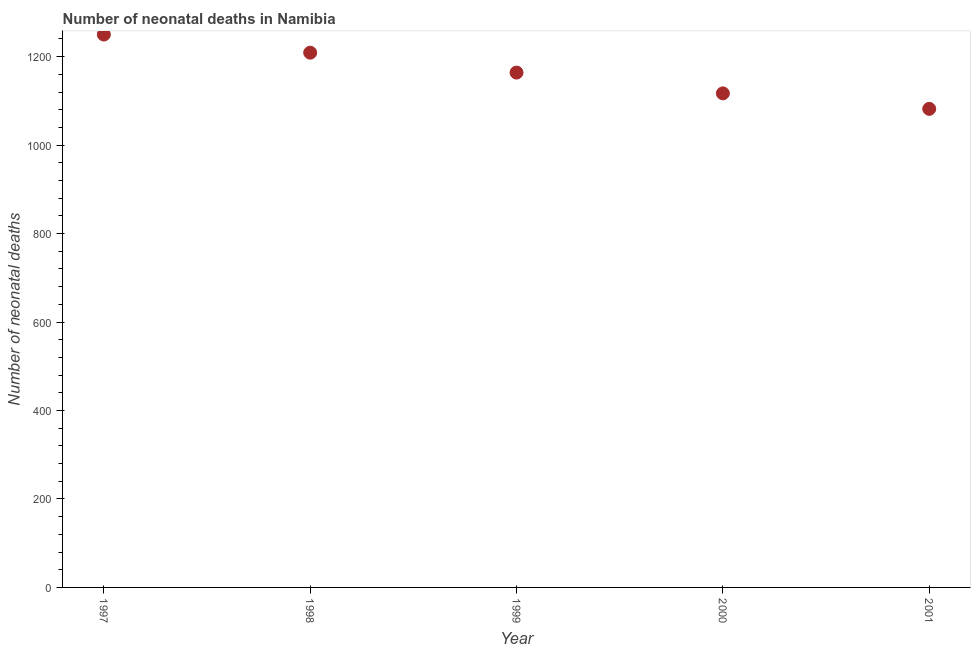What is the number of neonatal deaths in 2001?
Ensure brevity in your answer.  1082. Across all years, what is the maximum number of neonatal deaths?
Offer a terse response. 1250. Across all years, what is the minimum number of neonatal deaths?
Provide a succinct answer. 1082. In which year was the number of neonatal deaths maximum?
Provide a succinct answer. 1997. In which year was the number of neonatal deaths minimum?
Make the answer very short. 2001. What is the sum of the number of neonatal deaths?
Ensure brevity in your answer.  5822. What is the difference between the number of neonatal deaths in 1998 and 2000?
Provide a short and direct response. 92. What is the average number of neonatal deaths per year?
Provide a short and direct response. 1164.4. What is the median number of neonatal deaths?
Your response must be concise. 1164. What is the ratio of the number of neonatal deaths in 1999 to that in 2000?
Offer a very short reply. 1.04. Is the number of neonatal deaths in 1997 less than that in 1998?
Offer a terse response. No. Is the sum of the number of neonatal deaths in 1997 and 2001 greater than the maximum number of neonatal deaths across all years?
Offer a terse response. Yes. What is the difference between the highest and the lowest number of neonatal deaths?
Give a very brief answer. 168. In how many years, is the number of neonatal deaths greater than the average number of neonatal deaths taken over all years?
Provide a succinct answer. 2. Does the number of neonatal deaths monotonically increase over the years?
Ensure brevity in your answer.  No. How many years are there in the graph?
Offer a terse response. 5. Are the values on the major ticks of Y-axis written in scientific E-notation?
Give a very brief answer. No. Does the graph contain grids?
Offer a terse response. No. What is the title of the graph?
Your answer should be compact. Number of neonatal deaths in Namibia. What is the label or title of the Y-axis?
Offer a very short reply. Number of neonatal deaths. What is the Number of neonatal deaths in 1997?
Offer a very short reply. 1250. What is the Number of neonatal deaths in 1998?
Provide a short and direct response. 1209. What is the Number of neonatal deaths in 1999?
Keep it short and to the point. 1164. What is the Number of neonatal deaths in 2000?
Make the answer very short. 1117. What is the Number of neonatal deaths in 2001?
Your answer should be very brief. 1082. What is the difference between the Number of neonatal deaths in 1997 and 1998?
Make the answer very short. 41. What is the difference between the Number of neonatal deaths in 1997 and 2000?
Provide a short and direct response. 133. What is the difference between the Number of neonatal deaths in 1997 and 2001?
Ensure brevity in your answer.  168. What is the difference between the Number of neonatal deaths in 1998 and 2000?
Give a very brief answer. 92. What is the difference between the Number of neonatal deaths in 1998 and 2001?
Provide a short and direct response. 127. What is the difference between the Number of neonatal deaths in 1999 and 2000?
Provide a succinct answer. 47. What is the difference between the Number of neonatal deaths in 1999 and 2001?
Give a very brief answer. 82. What is the ratio of the Number of neonatal deaths in 1997 to that in 1998?
Your response must be concise. 1.03. What is the ratio of the Number of neonatal deaths in 1997 to that in 1999?
Offer a terse response. 1.07. What is the ratio of the Number of neonatal deaths in 1997 to that in 2000?
Offer a very short reply. 1.12. What is the ratio of the Number of neonatal deaths in 1997 to that in 2001?
Ensure brevity in your answer.  1.16. What is the ratio of the Number of neonatal deaths in 1998 to that in 1999?
Keep it short and to the point. 1.04. What is the ratio of the Number of neonatal deaths in 1998 to that in 2000?
Ensure brevity in your answer.  1.08. What is the ratio of the Number of neonatal deaths in 1998 to that in 2001?
Offer a very short reply. 1.12. What is the ratio of the Number of neonatal deaths in 1999 to that in 2000?
Your answer should be compact. 1.04. What is the ratio of the Number of neonatal deaths in 1999 to that in 2001?
Ensure brevity in your answer.  1.08. What is the ratio of the Number of neonatal deaths in 2000 to that in 2001?
Ensure brevity in your answer.  1.03. 